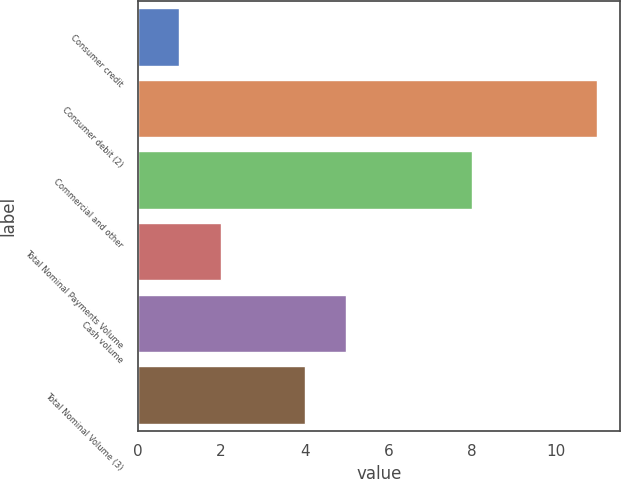<chart> <loc_0><loc_0><loc_500><loc_500><bar_chart><fcel>Consumer credit<fcel>Consumer debit (2)<fcel>Commercial and other<fcel>Total Nominal Payments Volume<fcel>Cash volume<fcel>Total Nominal Volume (3)<nl><fcel>1<fcel>11<fcel>8<fcel>2<fcel>5<fcel>4<nl></chart> 